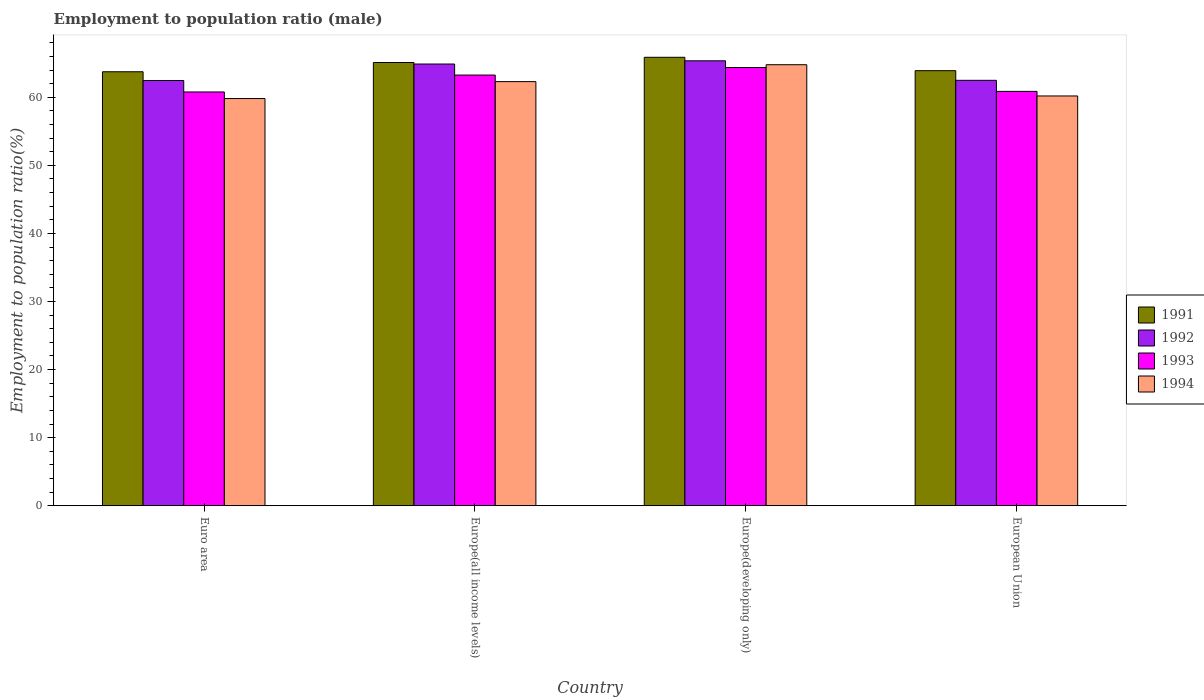Are the number of bars on each tick of the X-axis equal?
Provide a short and direct response. Yes. What is the employment to population ratio in 1992 in European Union?
Provide a succinct answer. 62.49. Across all countries, what is the maximum employment to population ratio in 1993?
Keep it short and to the point. 64.37. Across all countries, what is the minimum employment to population ratio in 1994?
Provide a succinct answer. 59.81. In which country was the employment to population ratio in 1991 maximum?
Make the answer very short. Europe(developing only). What is the total employment to population ratio in 1993 in the graph?
Make the answer very short. 249.28. What is the difference between the employment to population ratio in 1991 in Euro area and that in Europe(all income levels)?
Keep it short and to the point. -1.36. What is the difference between the employment to population ratio in 1994 in Europe(all income levels) and the employment to population ratio in 1993 in Euro area?
Offer a terse response. 1.52. What is the average employment to population ratio in 1994 per country?
Offer a terse response. 61.77. What is the difference between the employment to population ratio of/in 1992 and employment to population ratio of/in 1991 in Europe(all income levels)?
Offer a terse response. -0.22. What is the ratio of the employment to population ratio in 1991 in Euro area to that in European Union?
Provide a succinct answer. 1. Is the employment to population ratio in 1992 in Europe(developing only) less than that in European Union?
Provide a succinct answer. No. Is the difference between the employment to population ratio in 1992 in Euro area and Europe(developing only) greater than the difference between the employment to population ratio in 1991 in Euro area and Europe(developing only)?
Offer a very short reply. No. What is the difference between the highest and the second highest employment to population ratio in 1992?
Your response must be concise. -0.47. What is the difference between the highest and the lowest employment to population ratio in 1993?
Offer a very short reply. 3.59. In how many countries, is the employment to population ratio in 1993 greater than the average employment to population ratio in 1993 taken over all countries?
Give a very brief answer. 2. Is the sum of the employment to population ratio in 1994 in Euro area and European Union greater than the maximum employment to population ratio in 1993 across all countries?
Offer a very short reply. Yes. Is it the case that in every country, the sum of the employment to population ratio in 1994 and employment to population ratio in 1991 is greater than the sum of employment to population ratio in 1992 and employment to population ratio in 1993?
Provide a succinct answer. No. What does the 4th bar from the left in European Union represents?
Provide a short and direct response. 1994. What does the 2nd bar from the right in European Union represents?
Your answer should be compact. 1993. How many bars are there?
Your answer should be compact. 16. How many countries are there in the graph?
Your answer should be compact. 4. Are the values on the major ticks of Y-axis written in scientific E-notation?
Offer a terse response. No. Does the graph contain any zero values?
Keep it short and to the point. No. How many legend labels are there?
Provide a succinct answer. 4. What is the title of the graph?
Offer a very short reply. Employment to population ratio (male). What is the label or title of the X-axis?
Offer a very short reply. Country. What is the label or title of the Y-axis?
Give a very brief answer. Employment to population ratio(%). What is the Employment to population ratio(%) of 1991 in Euro area?
Ensure brevity in your answer.  63.75. What is the Employment to population ratio(%) of 1992 in Euro area?
Provide a succinct answer. 62.46. What is the Employment to population ratio(%) in 1993 in Euro area?
Make the answer very short. 60.78. What is the Employment to population ratio(%) in 1994 in Euro area?
Make the answer very short. 59.81. What is the Employment to population ratio(%) in 1991 in Europe(all income levels)?
Offer a very short reply. 65.11. What is the Employment to population ratio(%) in 1992 in Europe(all income levels)?
Your answer should be very brief. 64.88. What is the Employment to population ratio(%) in 1993 in Europe(all income levels)?
Your answer should be compact. 63.26. What is the Employment to population ratio(%) in 1994 in Europe(all income levels)?
Make the answer very short. 62.3. What is the Employment to population ratio(%) in 1991 in Europe(developing only)?
Give a very brief answer. 65.87. What is the Employment to population ratio(%) of 1992 in Europe(developing only)?
Give a very brief answer. 65.36. What is the Employment to population ratio(%) of 1993 in Europe(developing only)?
Offer a terse response. 64.37. What is the Employment to population ratio(%) of 1994 in Europe(developing only)?
Give a very brief answer. 64.78. What is the Employment to population ratio(%) of 1991 in European Union?
Your answer should be compact. 63.91. What is the Employment to population ratio(%) in 1992 in European Union?
Provide a succinct answer. 62.49. What is the Employment to population ratio(%) in 1993 in European Union?
Your response must be concise. 60.87. What is the Employment to population ratio(%) in 1994 in European Union?
Offer a terse response. 60.19. Across all countries, what is the maximum Employment to population ratio(%) in 1991?
Offer a terse response. 65.87. Across all countries, what is the maximum Employment to population ratio(%) of 1992?
Your answer should be very brief. 65.36. Across all countries, what is the maximum Employment to population ratio(%) of 1993?
Provide a succinct answer. 64.37. Across all countries, what is the maximum Employment to population ratio(%) of 1994?
Offer a very short reply. 64.78. Across all countries, what is the minimum Employment to population ratio(%) of 1991?
Give a very brief answer. 63.75. Across all countries, what is the minimum Employment to population ratio(%) in 1992?
Provide a short and direct response. 62.46. Across all countries, what is the minimum Employment to population ratio(%) in 1993?
Give a very brief answer. 60.78. Across all countries, what is the minimum Employment to population ratio(%) in 1994?
Make the answer very short. 59.81. What is the total Employment to population ratio(%) in 1991 in the graph?
Keep it short and to the point. 258.63. What is the total Employment to population ratio(%) in 1992 in the graph?
Keep it short and to the point. 255.2. What is the total Employment to population ratio(%) in 1993 in the graph?
Provide a succinct answer. 249.28. What is the total Employment to population ratio(%) in 1994 in the graph?
Ensure brevity in your answer.  247.09. What is the difference between the Employment to population ratio(%) in 1991 in Euro area and that in Europe(all income levels)?
Give a very brief answer. -1.36. What is the difference between the Employment to population ratio(%) in 1992 in Euro area and that in Europe(all income levels)?
Provide a short and direct response. -2.42. What is the difference between the Employment to population ratio(%) in 1993 in Euro area and that in Europe(all income levels)?
Keep it short and to the point. -2.48. What is the difference between the Employment to population ratio(%) in 1994 in Euro area and that in Europe(all income levels)?
Your answer should be compact. -2.49. What is the difference between the Employment to population ratio(%) in 1991 in Euro area and that in Europe(developing only)?
Provide a succinct answer. -2.13. What is the difference between the Employment to population ratio(%) in 1992 in Euro area and that in Europe(developing only)?
Keep it short and to the point. -2.89. What is the difference between the Employment to population ratio(%) of 1993 in Euro area and that in Europe(developing only)?
Your answer should be very brief. -3.59. What is the difference between the Employment to population ratio(%) in 1994 in Euro area and that in Europe(developing only)?
Ensure brevity in your answer.  -4.97. What is the difference between the Employment to population ratio(%) in 1991 in Euro area and that in European Union?
Provide a succinct answer. -0.16. What is the difference between the Employment to population ratio(%) in 1992 in Euro area and that in European Union?
Your response must be concise. -0.03. What is the difference between the Employment to population ratio(%) in 1993 in Euro area and that in European Union?
Make the answer very short. -0.09. What is the difference between the Employment to population ratio(%) in 1994 in Euro area and that in European Union?
Offer a terse response. -0.38. What is the difference between the Employment to population ratio(%) of 1991 in Europe(all income levels) and that in Europe(developing only)?
Make the answer very short. -0.77. What is the difference between the Employment to population ratio(%) of 1992 in Europe(all income levels) and that in Europe(developing only)?
Your response must be concise. -0.47. What is the difference between the Employment to population ratio(%) of 1993 in Europe(all income levels) and that in Europe(developing only)?
Offer a terse response. -1.11. What is the difference between the Employment to population ratio(%) in 1994 in Europe(all income levels) and that in Europe(developing only)?
Your response must be concise. -2.48. What is the difference between the Employment to population ratio(%) in 1991 in Europe(all income levels) and that in European Union?
Offer a terse response. 1.2. What is the difference between the Employment to population ratio(%) of 1992 in Europe(all income levels) and that in European Union?
Your answer should be compact. 2.39. What is the difference between the Employment to population ratio(%) in 1993 in Europe(all income levels) and that in European Union?
Your answer should be very brief. 2.4. What is the difference between the Employment to population ratio(%) in 1994 in Europe(all income levels) and that in European Union?
Give a very brief answer. 2.11. What is the difference between the Employment to population ratio(%) of 1991 in Europe(developing only) and that in European Union?
Your answer should be very brief. 1.97. What is the difference between the Employment to population ratio(%) in 1992 in Europe(developing only) and that in European Union?
Keep it short and to the point. 2.87. What is the difference between the Employment to population ratio(%) of 1993 in Europe(developing only) and that in European Union?
Your answer should be compact. 3.51. What is the difference between the Employment to population ratio(%) of 1994 in Europe(developing only) and that in European Union?
Ensure brevity in your answer.  4.59. What is the difference between the Employment to population ratio(%) in 1991 in Euro area and the Employment to population ratio(%) in 1992 in Europe(all income levels)?
Offer a terse response. -1.14. What is the difference between the Employment to population ratio(%) of 1991 in Euro area and the Employment to population ratio(%) of 1993 in Europe(all income levels)?
Your answer should be compact. 0.48. What is the difference between the Employment to population ratio(%) in 1991 in Euro area and the Employment to population ratio(%) in 1994 in Europe(all income levels)?
Your answer should be very brief. 1.45. What is the difference between the Employment to population ratio(%) in 1992 in Euro area and the Employment to population ratio(%) in 1993 in Europe(all income levels)?
Make the answer very short. -0.8. What is the difference between the Employment to population ratio(%) of 1992 in Euro area and the Employment to population ratio(%) of 1994 in Europe(all income levels)?
Your response must be concise. 0.16. What is the difference between the Employment to population ratio(%) of 1993 in Euro area and the Employment to population ratio(%) of 1994 in Europe(all income levels)?
Provide a succinct answer. -1.52. What is the difference between the Employment to population ratio(%) in 1991 in Euro area and the Employment to population ratio(%) in 1992 in Europe(developing only)?
Give a very brief answer. -1.61. What is the difference between the Employment to population ratio(%) in 1991 in Euro area and the Employment to population ratio(%) in 1993 in Europe(developing only)?
Provide a succinct answer. -0.62. What is the difference between the Employment to population ratio(%) in 1991 in Euro area and the Employment to population ratio(%) in 1994 in Europe(developing only)?
Offer a very short reply. -1.04. What is the difference between the Employment to population ratio(%) in 1992 in Euro area and the Employment to population ratio(%) in 1993 in Europe(developing only)?
Provide a succinct answer. -1.91. What is the difference between the Employment to population ratio(%) of 1992 in Euro area and the Employment to population ratio(%) of 1994 in Europe(developing only)?
Your answer should be compact. -2.32. What is the difference between the Employment to population ratio(%) in 1993 in Euro area and the Employment to population ratio(%) in 1994 in Europe(developing only)?
Provide a succinct answer. -4. What is the difference between the Employment to population ratio(%) of 1991 in Euro area and the Employment to population ratio(%) of 1992 in European Union?
Your response must be concise. 1.26. What is the difference between the Employment to population ratio(%) in 1991 in Euro area and the Employment to population ratio(%) in 1993 in European Union?
Your answer should be very brief. 2.88. What is the difference between the Employment to population ratio(%) of 1991 in Euro area and the Employment to population ratio(%) of 1994 in European Union?
Ensure brevity in your answer.  3.56. What is the difference between the Employment to population ratio(%) of 1992 in Euro area and the Employment to population ratio(%) of 1993 in European Union?
Ensure brevity in your answer.  1.6. What is the difference between the Employment to population ratio(%) of 1992 in Euro area and the Employment to population ratio(%) of 1994 in European Union?
Make the answer very short. 2.27. What is the difference between the Employment to population ratio(%) of 1993 in Euro area and the Employment to population ratio(%) of 1994 in European Union?
Give a very brief answer. 0.59. What is the difference between the Employment to population ratio(%) of 1991 in Europe(all income levels) and the Employment to population ratio(%) of 1992 in Europe(developing only)?
Ensure brevity in your answer.  -0.25. What is the difference between the Employment to population ratio(%) in 1991 in Europe(all income levels) and the Employment to population ratio(%) in 1993 in Europe(developing only)?
Your response must be concise. 0.73. What is the difference between the Employment to population ratio(%) in 1991 in Europe(all income levels) and the Employment to population ratio(%) in 1994 in Europe(developing only)?
Ensure brevity in your answer.  0.32. What is the difference between the Employment to population ratio(%) in 1992 in Europe(all income levels) and the Employment to population ratio(%) in 1993 in Europe(developing only)?
Your answer should be very brief. 0.51. What is the difference between the Employment to population ratio(%) in 1992 in Europe(all income levels) and the Employment to population ratio(%) in 1994 in Europe(developing only)?
Keep it short and to the point. 0.1. What is the difference between the Employment to population ratio(%) in 1993 in Europe(all income levels) and the Employment to population ratio(%) in 1994 in Europe(developing only)?
Provide a short and direct response. -1.52. What is the difference between the Employment to population ratio(%) in 1991 in Europe(all income levels) and the Employment to population ratio(%) in 1992 in European Union?
Provide a succinct answer. 2.61. What is the difference between the Employment to population ratio(%) in 1991 in Europe(all income levels) and the Employment to population ratio(%) in 1993 in European Union?
Your answer should be very brief. 4.24. What is the difference between the Employment to population ratio(%) in 1991 in Europe(all income levels) and the Employment to population ratio(%) in 1994 in European Union?
Provide a succinct answer. 4.91. What is the difference between the Employment to population ratio(%) of 1992 in Europe(all income levels) and the Employment to population ratio(%) of 1993 in European Union?
Your answer should be compact. 4.02. What is the difference between the Employment to population ratio(%) in 1992 in Europe(all income levels) and the Employment to population ratio(%) in 1994 in European Union?
Provide a short and direct response. 4.69. What is the difference between the Employment to population ratio(%) of 1993 in Europe(all income levels) and the Employment to population ratio(%) of 1994 in European Union?
Give a very brief answer. 3.07. What is the difference between the Employment to population ratio(%) of 1991 in Europe(developing only) and the Employment to population ratio(%) of 1992 in European Union?
Ensure brevity in your answer.  3.38. What is the difference between the Employment to population ratio(%) of 1991 in Europe(developing only) and the Employment to population ratio(%) of 1993 in European Union?
Offer a very short reply. 5.01. What is the difference between the Employment to population ratio(%) of 1991 in Europe(developing only) and the Employment to population ratio(%) of 1994 in European Union?
Give a very brief answer. 5.68. What is the difference between the Employment to population ratio(%) of 1992 in Europe(developing only) and the Employment to population ratio(%) of 1993 in European Union?
Provide a short and direct response. 4.49. What is the difference between the Employment to population ratio(%) in 1992 in Europe(developing only) and the Employment to population ratio(%) in 1994 in European Union?
Ensure brevity in your answer.  5.16. What is the difference between the Employment to population ratio(%) in 1993 in Europe(developing only) and the Employment to population ratio(%) in 1994 in European Union?
Offer a very short reply. 4.18. What is the average Employment to population ratio(%) in 1991 per country?
Keep it short and to the point. 64.66. What is the average Employment to population ratio(%) in 1992 per country?
Make the answer very short. 63.8. What is the average Employment to population ratio(%) in 1993 per country?
Your response must be concise. 62.32. What is the average Employment to population ratio(%) in 1994 per country?
Give a very brief answer. 61.77. What is the difference between the Employment to population ratio(%) in 1991 and Employment to population ratio(%) in 1992 in Euro area?
Your answer should be compact. 1.29. What is the difference between the Employment to population ratio(%) in 1991 and Employment to population ratio(%) in 1993 in Euro area?
Make the answer very short. 2.97. What is the difference between the Employment to population ratio(%) in 1991 and Employment to population ratio(%) in 1994 in Euro area?
Your answer should be compact. 3.93. What is the difference between the Employment to population ratio(%) of 1992 and Employment to population ratio(%) of 1993 in Euro area?
Your answer should be very brief. 1.68. What is the difference between the Employment to population ratio(%) in 1992 and Employment to population ratio(%) in 1994 in Euro area?
Provide a short and direct response. 2.65. What is the difference between the Employment to population ratio(%) of 1993 and Employment to population ratio(%) of 1994 in Euro area?
Make the answer very short. 0.97. What is the difference between the Employment to population ratio(%) in 1991 and Employment to population ratio(%) in 1992 in Europe(all income levels)?
Your answer should be compact. 0.22. What is the difference between the Employment to population ratio(%) of 1991 and Employment to population ratio(%) of 1993 in Europe(all income levels)?
Provide a short and direct response. 1.84. What is the difference between the Employment to population ratio(%) of 1991 and Employment to population ratio(%) of 1994 in Europe(all income levels)?
Your answer should be very brief. 2.81. What is the difference between the Employment to population ratio(%) in 1992 and Employment to population ratio(%) in 1993 in Europe(all income levels)?
Your answer should be very brief. 1.62. What is the difference between the Employment to population ratio(%) of 1992 and Employment to population ratio(%) of 1994 in Europe(all income levels)?
Ensure brevity in your answer.  2.58. What is the difference between the Employment to population ratio(%) of 1993 and Employment to population ratio(%) of 1994 in Europe(all income levels)?
Offer a very short reply. 0.97. What is the difference between the Employment to population ratio(%) of 1991 and Employment to population ratio(%) of 1992 in Europe(developing only)?
Provide a short and direct response. 0.52. What is the difference between the Employment to population ratio(%) of 1991 and Employment to population ratio(%) of 1993 in Europe(developing only)?
Make the answer very short. 1.5. What is the difference between the Employment to population ratio(%) of 1991 and Employment to population ratio(%) of 1994 in Europe(developing only)?
Keep it short and to the point. 1.09. What is the difference between the Employment to population ratio(%) in 1992 and Employment to population ratio(%) in 1994 in Europe(developing only)?
Make the answer very short. 0.57. What is the difference between the Employment to population ratio(%) of 1993 and Employment to population ratio(%) of 1994 in Europe(developing only)?
Provide a succinct answer. -0.41. What is the difference between the Employment to population ratio(%) of 1991 and Employment to population ratio(%) of 1992 in European Union?
Provide a succinct answer. 1.42. What is the difference between the Employment to population ratio(%) in 1991 and Employment to population ratio(%) in 1993 in European Union?
Provide a succinct answer. 3.04. What is the difference between the Employment to population ratio(%) in 1991 and Employment to population ratio(%) in 1994 in European Union?
Your response must be concise. 3.71. What is the difference between the Employment to population ratio(%) in 1992 and Employment to population ratio(%) in 1993 in European Union?
Provide a short and direct response. 1.62. What is the difference between the Employment to population ratio(%) in 1992 and Employment to population ratio(%) in 1994 in European Union?
Your answer should be compact. 2.3. What is the difference between the Employment to population ratio(%) of 1993 and Employment to population ratio(%) of 1994 in European Union?
Provide a succinct answer. 0.67. What is the ratio of the Employment to population ratio(%) of 1991 in Euro area to that in Europe(all income levels)?
Offer a terse response. 0.98. What is the ratio of the Employment to population ratio(%) in 1992 in Euro area to that in Europe(all income levels)?
Offer a very short reply. 0.96. What is the ratio of the Employment to population ratio(%) of 1993 in Euro area to that in Europe(all income levels)?
Offer a terse response. 0.96. What is the ratio of the Employment to population ratio(%) of 1994 in Euro area to that in Europe(all income levels)?
Offer a very short reply. 0.96. What is the ratio of the Employment to population ratio(%) of 1992 in Euro area to that in Europe(developing only)?
Provide a succinct answer. 0.96. What is the ratio of the Employment to population ratio(%) of 1993 in Euro area to that in Europe(developing only)?
Give a very brief answer. 0.94. What is the ratio of the Employment to population ratio(%) of 1994 in Euro area to that in Europe(developing only)?
Your answer should be very brief. 0.92. What is the ratio of the Employment to population ratio(%) in 1992 in Euro area to that in European Union?
Offer a very short reply. 1. What is the ratio of the Employment to population ratio(%) in 1993 in Euro area to that in European Union?
Your answer should be very brief. 1. What is the ratio of the Employment to population ratio(%) of 1991 in Europe(all income levels) to that in Europe(developing only)?
Your answer should be very brief. 0.99. What is the ratio of the Employment to population ratio(%) of 1992 in Europe(all income levels) to that in Europe(developing only)?
Offer a terse response. 0.99. What is the ratio of the Employment to population ratio(%) in 1993 in Europe(all income levels) to that in Europe(developing only)?
Your answer should be very brief. 0.98. What is the ratio of the Employment to population ratio(%) in 1994 in Europe(all income levels) to that in Europe(developing only)?
Offer a terse response. 0.96. What is the ratio of the Employment to population ratio(%) in 1991 in Europe(all income levels) to that in European Union?
Offer a very short reply. 1.02. What is the ratio of the Employment to population ratio(%) of 1992 in Europe(all income levels) to that in European Union?
Your response must be concise. 1.04. What is the ratio of the Employment to population ratio(%) in 1993 in Europe(all income levels) to that in European Union?
Offer a terse response. 1.04. What is the ratio of the Employment to population ratio(%) in 1994 in Europe(all income levels) to that in European Union?
Your response must be concise. 1.03. What is the ratio of the Employment to population ratio(%) in 1991 in Europe(developing only) to that in European Union?
Make the answer very short. 1.03. What is the ratio of the Employment to population ratio(%) of 1992 in Europe(developing only) to that in European Union?
Ensure brevity in your answer.  1.05. What is the ratio of the Employment to population ratio(%) in 1993 in Europe(developing only) to that in European Union?
Your response must be concise. 1.06. What is the ratio of the Employment to population ratio(%) of 1994 in Europe(developing only) to that in European Union?
Offer a very short reply. 1.08. What is the difference between the highest and the second highest Employment to population ratio(%) of 1991?
Your answer should be compact. 0.77. What is the difference between the highest and the second highest Employment to population ratio(%) of 1992?
Make the answer very short. 0.47. What is the difference between the highest and the second highest Employment to population ratio(%) in 1993?
Your answer should be compact. 1.11. What is the difference between the highest and the second highest Employment to population ratio(%) of 1994?
Offer a very short reply. 2.48. What is the difference between the highest and the lowest Employment to population ratio(%) in 1991?
Provide a short and direct response. 2.13. What is the difference between the highest and the lowest Employment to population ratio(%) in 1992?
Make the answer very short. 2.89. What is the difference between the highest and the lowest Employment to population ratio(%) in 1993?
Give a very brief answer. 3.59. What is the difference between the highest and the lowest Employment to population ratio(%) of 1994?
Your answer should be very brief. 4.97. 